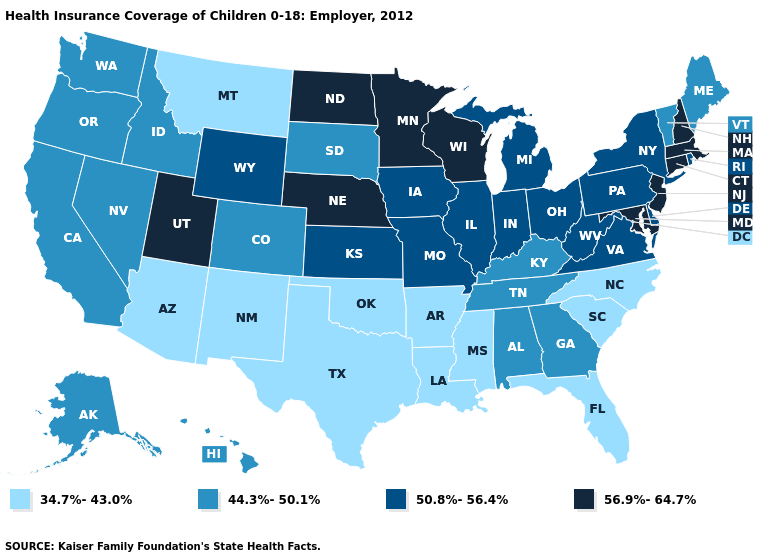Does the map have missing data?
Short answer required. No. Does California have the same value as Colorado?
Give a very brief answer. Yes. What is the value of Minnesota?
Write a very short answer. 56.9%-64.7%. What is the value of Utah?
Short answer required. 56.9%-64.7%. Among the states that border Florida , which have the highest value?
Concise answer only. Alabama, Georgia. Name the states that have a value in the range 56.9%-64.7%?
Answer briefly. Connecticut, Maryland, Massachusetts, Minnesota, Nebraska, New Hampshire, New Jersey, North Dakota, Utah, Wisconsin. Name the states that have a value in the range 50.8%-56.4%?
Short answer required. Delaware, Illinois, Indiana, Iowa, Kansas, Michigan, Missouri, New York, Ohio, Pennsylvania, Rhode Island, Virginia, West Virginia, Wyoming. Does the first symbol in the legend represent the smallest category?
Keep it brief. Yes. What is the lowest value in states that border Texas?
Be succinct. 34.7%-43.0%. What is the value of Arkansas?
Short answer required. 34.7%-43.0%. What is the value of North Dakota?
Concise answer only. 56.9%-64.7%. Name the states that have a value in the range 34.7%-43.0%?
Concise answer only. Arizona, Arkansas, Florida, Louisiana, Mississippi, Montana, New Mexico, North Carolina, Oklahoma, South Carolina, Texas. Does the first symbol in the legend represent the smallest category?
Give a very brief answer. Yes. Which states have the lowest value in the USA?
Write a very short answer. Arizona, Arkansas, Florida, Louisiana, Mississippi, Montana, New Mexico, North Carolina, Oklahoma, South Carolina, Texas. What is the highest value in states that border Utah?
Give a very brief answer. 50.8%-56.4%. 